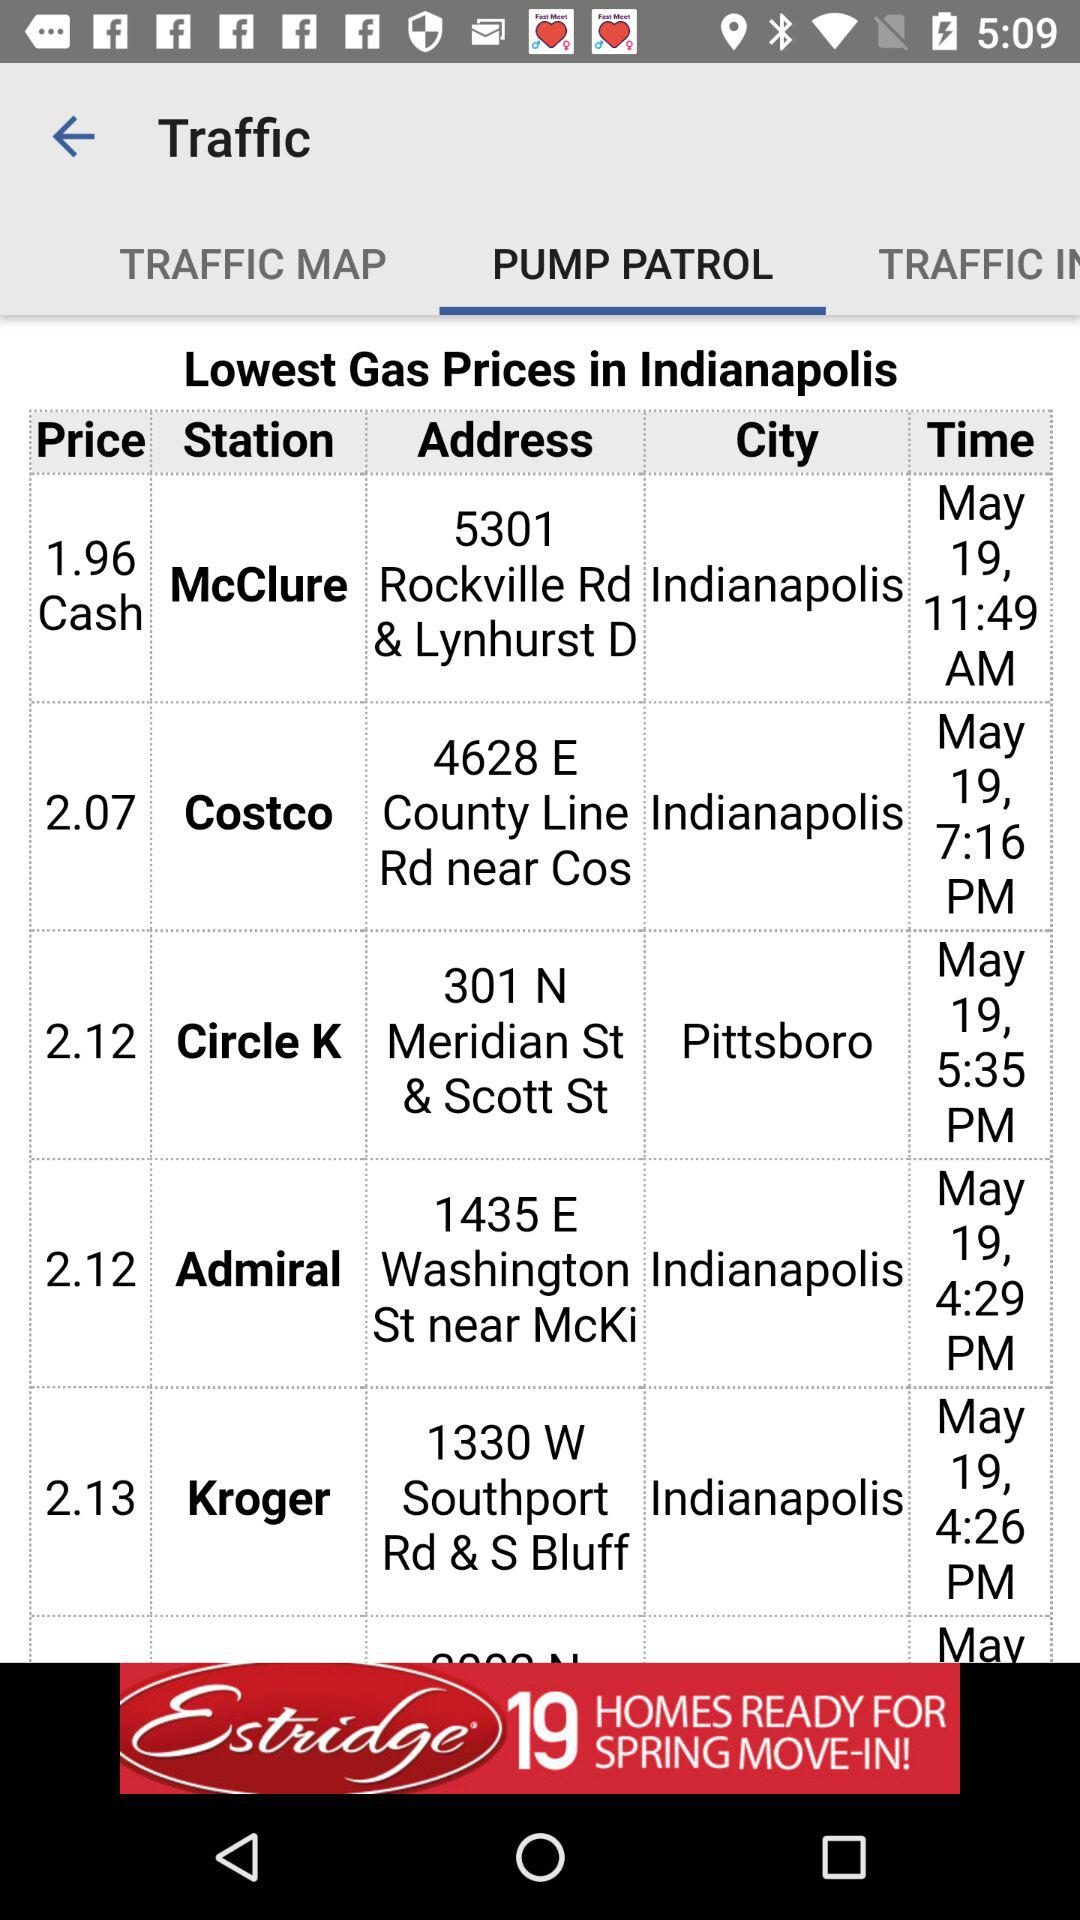What is the city of Circle K station? The city is "Pittsboro". 